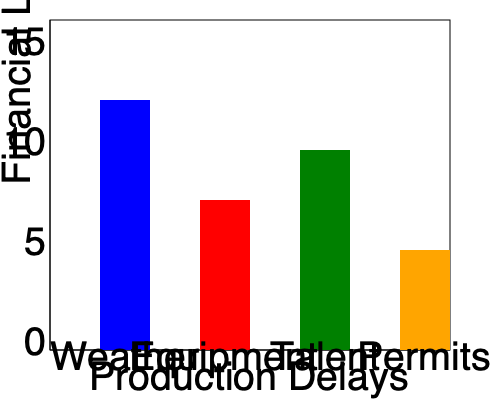Based on the bar graph showing financial losses due to various production delays, which type of delay caused the highest financial loss, and what is the approximate difference in millions of dollars between the highest and lowest loss categories? To answer this question, we need to analyze the bar graph and follow these steps:

1. Identify the highest bar:
   The blue bar representing "Weather" delays is the tallest, reaching approximately $12.5 million.

2. Identify the lowest bar:
   The orange bar representing "Permits" delays is the shortest, reaching approximately $5 million.

3. Calculate the difference:
   Highest (Weather) - Lowest (Permits) = $12.5 million - $5 million = $7.5 million

Therefore, weather-related delays caused the highest financial loss, and the approximate difference between the highest (weather) and lowest (permits) loss categories is $7.5 million.
Answer: Weather; $7.5 million 